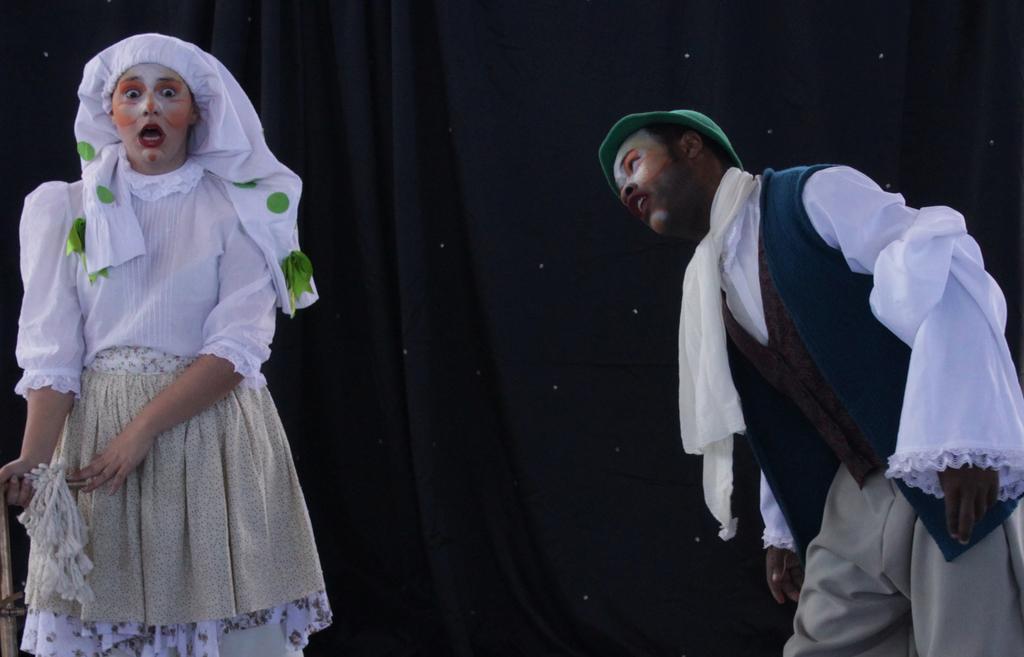Describe this image in one or two sentences. In the image there is a lady and a man with costumes and makeup. Behind them there is a curtain. 